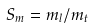Convert formula to latex. <formula><loc_0><loc_0><loc_500><loc_500>S _ { m } = m _ { l } / m _ { t }</formula> 